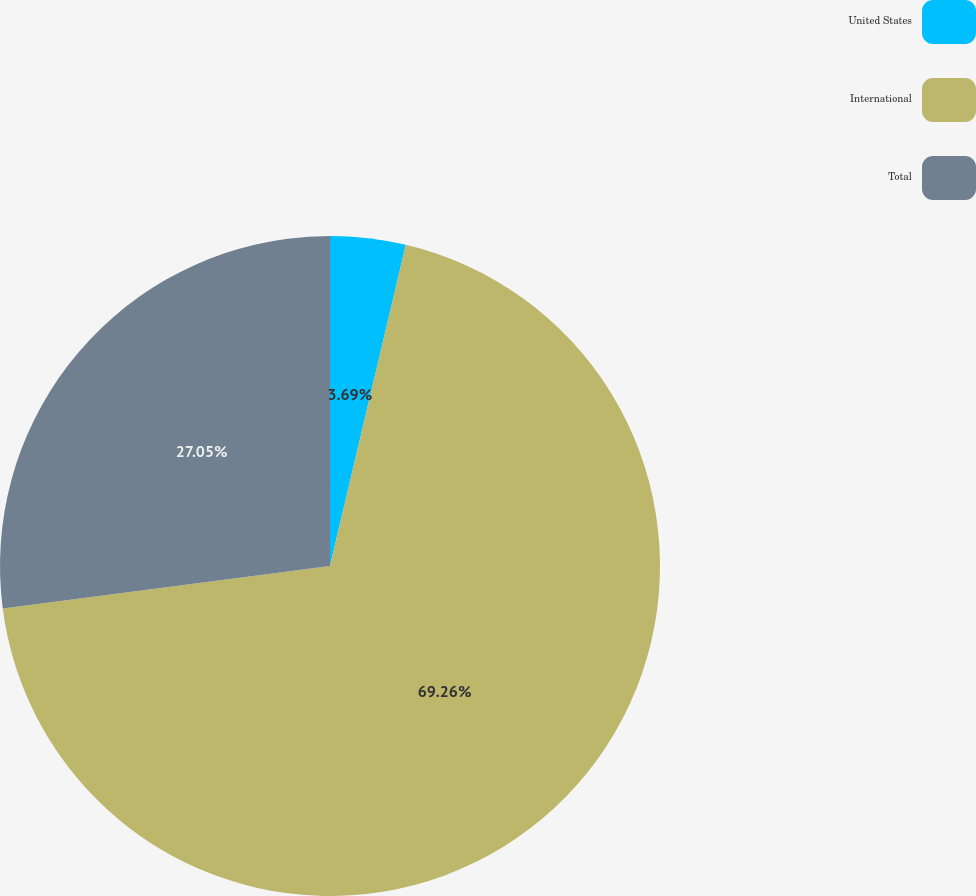<chart> <loc_0><loc_0><loc_500><loc_500><pie_chart><fcel>United States<fcel>International<fcel>Total<nl><fcel>3.69%<fcel>69.26%<fcel>27.05%<nl></chart> 